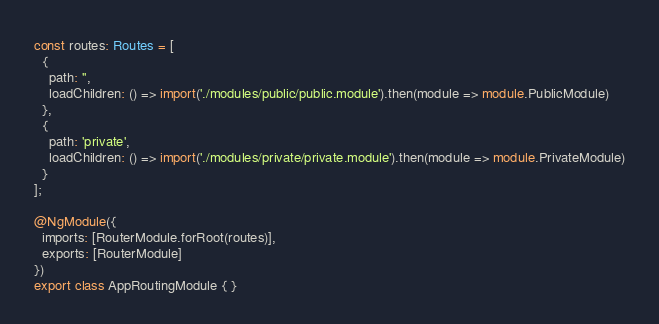<code> <loc_0><loc_0><loc_500><loc_500><_TypeScript_>

const routes: Routes = [
  {
    path: '',
    loadChildren: () => import('./modules/public/public.module').then(module => module.PublicModule)
  },
  {
    path: 'private',
    loadChildren: () => import('./modules/private/private.module').then(module => module.PrivateModule)
  }
];

@NgModule({
  imports: [RouterModule.forRoot(routes)],
  exports: [RouterModule]
})
export class AppRoutingModule { }
</code> 